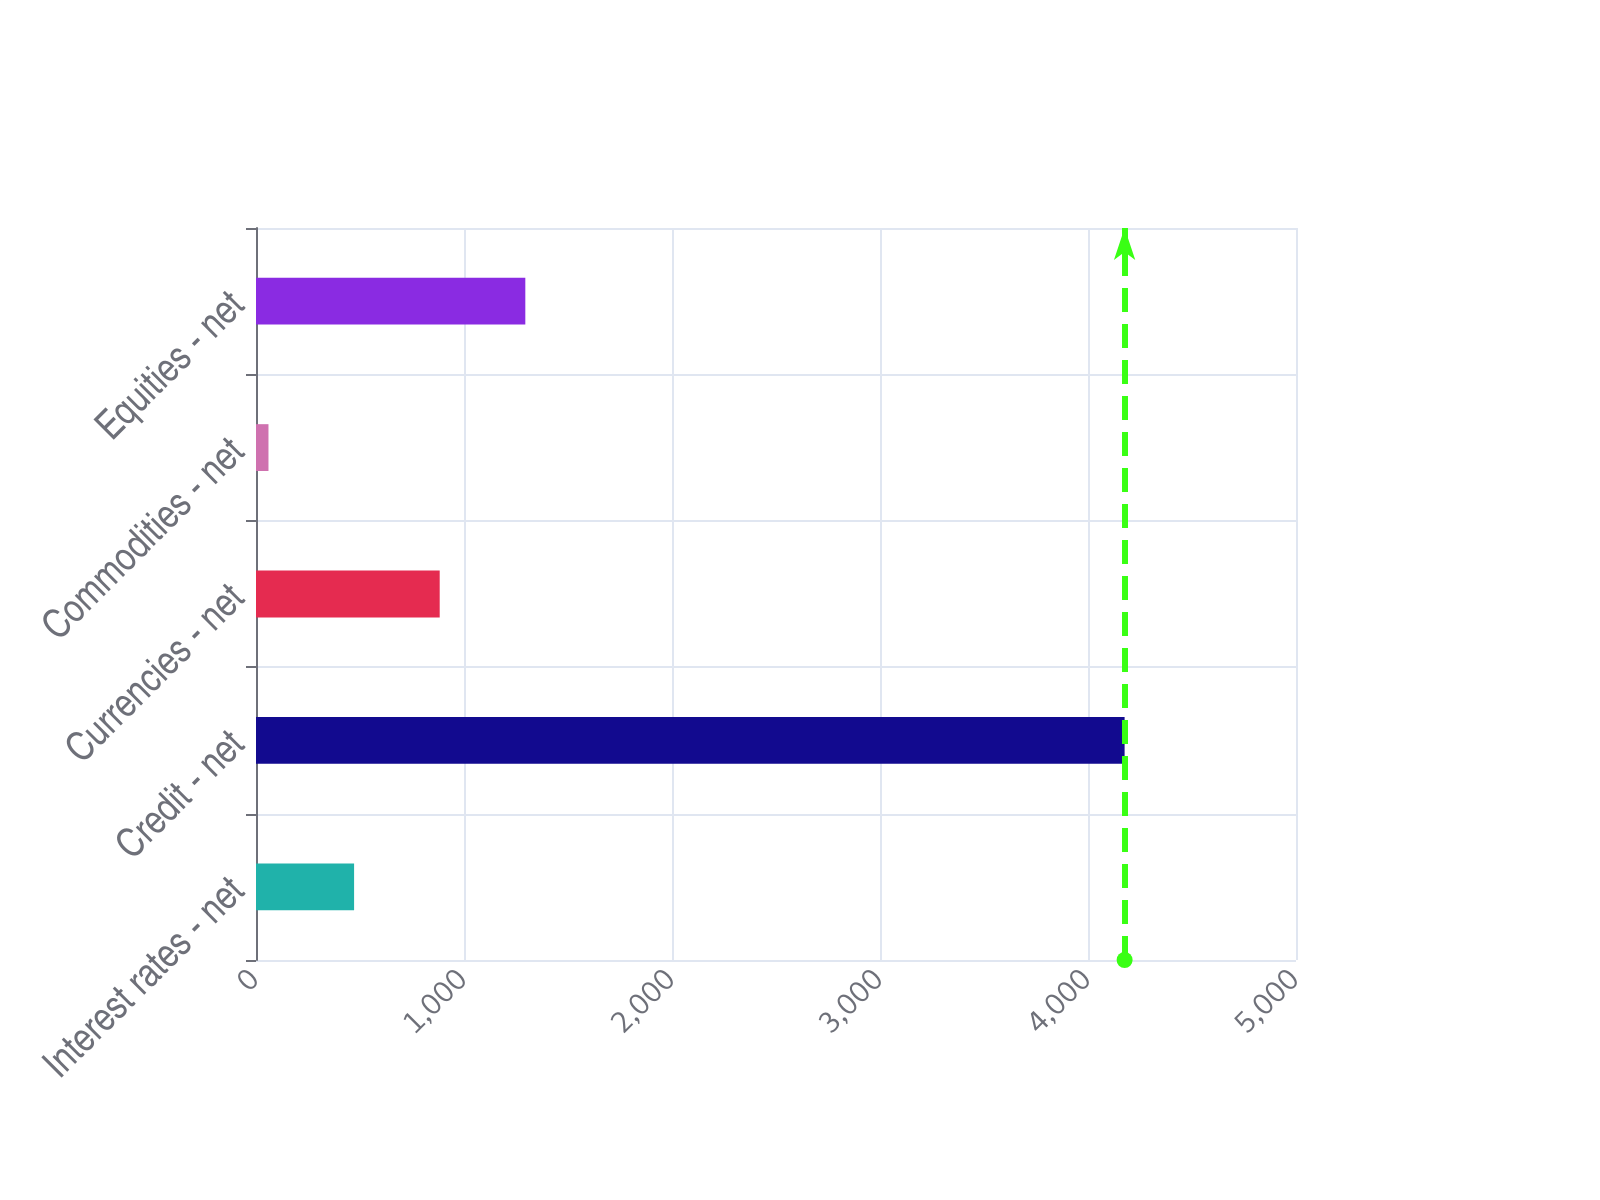<chart> <loc_0><loc_0><loc_500><loc_500><bar_chart><fcel>Interest rates - net<fcel>Credit - net<fcel>Currencies - net<fcel>Commodities - net<fcel>Equities - net<nl><fcel>471.6<fcel>4176<fcel>883.2<fcel>60<fcel>1294.8<nl></chart> 